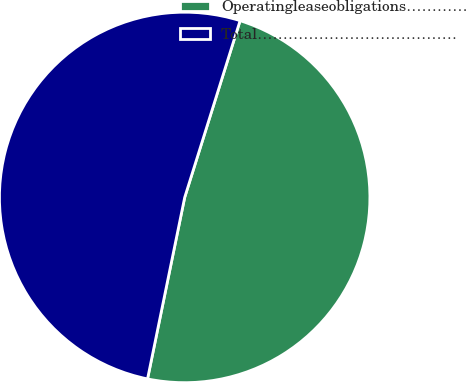Convert chart. <chart><loc_0><loc_0><loc_500><loc_500><pie_chart><fcel>Operatingleaseobligations…………<fcel>Total…………………………………<nl><fcel>48.38%<fcel>51.62%<nl></chart> 